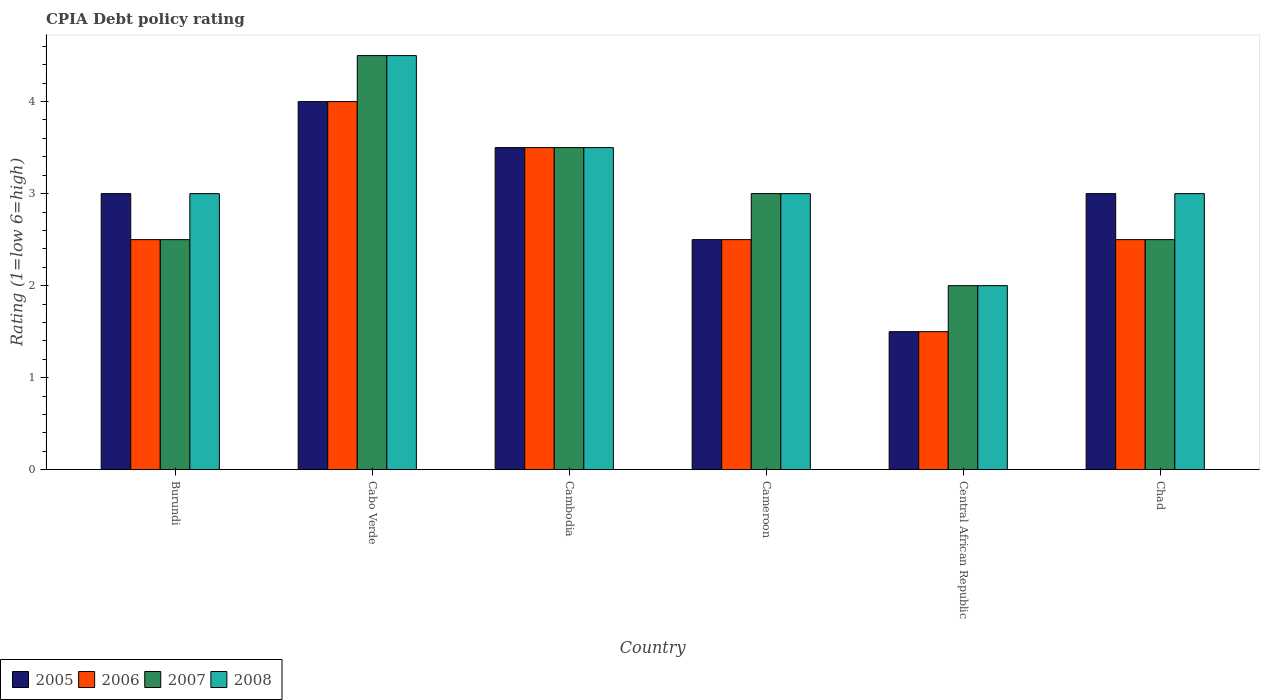How many groups of bars are there?
Offer a very short reply. 6. How many bars are there on the 5th tick from the right?
Keep it short and to the point. 4. What is the label of the 1st group of bars from the left?
Your response must be concise. Burundi. In how many cases, is the number of bars for a given country not equal to the number of legend labels?
Your response must be concise. 0. Across all countries, what is the maximum CPIA rating in 2005?
Offer a terse response. 4. Across all countries, what is the minimum CPIA rating in 2007?
Offer a very short reply. 2. In which country was the CPIA rating in 2005 maximum?
Give a very brief answer. Cabo Verde. In which country was the CPIA rating in 2008 minimum?
Make the answer very short. Central African Republic. What is the difference between the CPIA rating in 2005 in Burundi and that in Cambodia?
Keep it short and to the point. -0.5. What is the average CPIA rating in 2006 per country?
Your response must be concise. 2.75. What is the difference between the CPIA rating of/in 2005 and CPIA rating of/in 2007 in Chad?
Offer a terse response. 0.5. In how many countries, is the CPIA rating in 2006 greater than 3?
Provide a succinct answer. 2. What is the ratio of the CPIA rating in 2006 in Cabo Verde to that in Chad?
Your answer should be compact. 1.6. Is the CPIA rating in 2006 in Cabo Verde less than that in Central African Republic?
Your answer should be very brief. No. Is the difference between the CPIA rating in 2005 in Burundi and Cabo Verde greater than the difference between the CPIA rating in 2007 in Burundi and Cabo Verde?
Keep it short and to the point. Yes. What is the difference between the highest and the lowest CPIA rating in 2008?
Keep it short and to the point. 2.5. In how many countries, is the CPIA rating in 2008 greater than the average CPIA rating in 2008 taken over all countries?
Make the answer very short. 2. Is it the case that in every country, the sum of the CPIA rating in 2007 and CPIA rating in 2008 is greater than the sum of CPIA rating in 2006 and CPIA rating in 2005?
Offer a very short reply. No. Is it the case that in every country, the sum of the CPIA rating in 2006 and CPIA rating in 2005 is greater than the CPIA rating in 2008?
Offer a very short reply. Yes. How many countries are there in the graph?
Offer a terse response. 6. What is the difference between two consecutive major ticks on the Y-axis?
Keep it short and to the point. 1. Are the values on the major ticks of Y-axis written in scientific E-notation?
Provide a succinct answer. No. Does the graph contain any zero values?
Give a very brief answer. No. How many legend labels are there?
Ensure brevity in your answer.  4. How are the legend labels stacked?
Your response must be concise. Horizontal. What is the title of the graph?
Provide a succinct answer. CPIA Debt policy rating. What is the label or title of the X-axis?
Make the answer very short. Country. What is the Rating (1=low 6=high) of 2007 in Burundi?
Offer a terse response. 2.5. What is the Rating (1=low 6=high) in 2008 in Burundi?
Make the answer very short. 3. What is the Rating (1=low 6=high) in 2005 in Cabo Verde?
Your answer should be very brief. 4. What is the Rating (1=low 6=high) in 2006 in Cabo Verde?
Keep it short and to the point. 4. What is the Rating (1=low 6=high) of 2008 in Cabo Verde?
Offer a very short reply. 4.5. What is the Rating (1=low 6=high) in 2006 in Cambodia?
Keep it short and to the point. 3.5. What is the Rating (1=low 6=high) of 2005 in Cameroon?
Provide a short and direct response. 2.5. What is the Rating (1=low 6=high) in 2007 in Cameroon?
Offer a very short reply. 3. What is the Rating (1=low 6=high) of 2005 in Central African Republic?
Offer a very short reply. 1.5. What is the Rating (1=low 6=high) of 2006 in Central African Republic?
Keep it short and to the point. 1.5. What is the Rating (1=low 6=high) of 2005 in Chad?
Give a very brief answer. 3. What is the Rating (1=low 6=high) in 2006 in Chad?
Your response must be concise. 2.5. What is the Rating (1=low 6=high) in 2007 in Chad?
Your response must be concise. 2.5. Across all countries, what is the minimum Rating (1=low 6=high) in 2006?
Your response must be concise. 1.5. Across all countries, what is the minimum Rating (1=low 6=high) in 2007?
Make the answer very short. 2. Across all countries, what is the minimum Rating (1=low 6=high) of 2008?
Provide a short and direct response. 2. What is the total Rating (1=low 6=high) in 2006 in the graph?
Give a very brief answer. 16.5. What is the total Rating (1=low 6=high) of 2007 in the graph?
Offer a terse response. 18. What is the difference between the Rating (1=low 6=high) of 2006 in Burundi and that in Cabo Verde?
Your response must be concise. -1.5. What is the difference between the Rating (1=low 6=high) of 2007 in Burundi and that in Cabo Verde?
Provide a short and direct response. -2. What is the difference between the Rating (1=low 6=high) in 2008 in Burundi and that in Cabo Verde?
Give a very brief answer. -1.5. What is the difference between the Rating (1=low 6=high) in 2007 in Burundi and that in Cambodia?
Your answer should be very brief. -1. What is the difference between the Rating (1=low 6=high) of 2005 in Burundi and that in Cameroon?
Your answer should be compact. 0.5. What is the difference between the Rating (1=low 6=high) of 2006 in Burundi and that in Cameroon?
Provide a short and direct response. 0. What is the difference between the Rating (1=low 6=high) of 2007 in Burundi and that in Cameroon?
Your response must be concise. -0.5. What is the difference between the Rating (1=low 6=high) of 2005 in Burundi and that in Central African Republic?
Ensure brevity in your answer.  1.5. What is the difference between the Rating (1=low 6=high) in 2006 in Burundi and that in Chad?
Your answer should be compact. 0. What is the difference between the Rating (1=low 6=high) in 2008 in Burundi and that in Chad?
Your answer should be very brief. 0. What is the difference between the Rating (1=low 6=high) in 2005 in Cabo Verde and that in Cambodia?
Keep it short and to the point. 0.5. What is the difference between the Rating (1=low 6=high) of 2006 in Cabo Verde and that in Cambodia?
Keep it short and to the point. 0.5. What is the difference between the Rating (1=low 6=high) in 2007 in Cabo Verde and that in Cambodia?
Keep it short and to the point. 1. What is the difference between the Rating (1=low 6=high) of 2008 in Cabo Verde and that in Cambodia?
Make the answer very short. 1. What is the difference between the Rating (1=low 6=high) in 2007 in Cabo Verde and that in Cameroon?
Keep it short and to the point. 1.5. What is the difference between the Rating (1=low 6=high) in 2008 in Cabo Verde and that in Cameroon?
Keep it short and to the point. 1.5. What is the difference between the Rating (1=low 6=high) in 2006 in Cabo Verde and that in Central African Republic?
Offer a terse response. 2.5. What is the difference between the Rating (1=low 6=high) in 2007 in Cabo Verde and that in Central African Republic?
Ensure brevity in your answer.  2.5. What is the difference between the Rating (1=low 6=high) in 2005 in Cabo Verde and that in Chad?
Make the answer very short. 1. What is the difference between the Rating (1=low 6=high) of 2006 in Cabo Verde and that in Chad?
Provide a short and direct response. 1.5. What is the difference between the Rating (1=low 6=high) of 2008 in Cabo Verde and that in Chad?
Your answer should be compact. 1.5. What is the difference between the Rating (1=low 6=high) in 2005 in Cambodia and that in Cameroon?
Ensure brevity in your answer.  1. What is the difference between the Rating (1=low 6=high) in 2006 in Cambodia and that in Cameroon?
Your answer should be very brief. 1. What is the difference between the Rating (1=low 6=high) in 2007 in Cambodia and that in Cameroon?
Give a very brief answer. 0.5. What is the difference between the Rating (1=low 6=high) of 2008 in Cambodia and that in Cameroon?
Offer a terse response. 0.5. What is the difference between the Rating (1=low 6=high) in 2005 in Cambodia and that in Central African Republic?
Offer a terse response. 2. What is the difference between the Rating (1=low 6=high) in 2006 in Cambodia and that in Central African Republic?
Provide a succinct answer. 2. What is the difference between the Rating (1=low 6=high) in 2008 in Cambodia and that in Central African Republic?
Keep it short and to the point. 1.5. What is the difference between the Rating (1=low 6=high) of 2006 in Cambodia and that in Chad?
Make the answer very short. 1. What is the difference between the Rating (1=low 6=high) of 2007 in Cambodia and that in Chad?
Give a very brief answer. 1. What is the difference between the Rating (1=low 6=high) in 2005 in Cameroon and that in Chad?
Ensure brevity in your answer.  -0.5. What is the difference between the Rating (1=low 6=high) of 2008 in Cameroon and that in Chad?
Your answer should be compact. 0. What is the difference between the Rating (1=low 6=high) of 2005 in Central African Republic and that in Chad?
Offer a very short reply. -1.5. What is the difference between the Rating (1=low 6=high) of 2006 in Burundi and the Rating (1=low 6=high) of 2008 in Cabo Verde?
Provide a short and direct response. -2. What is the difference between the Rating (1=low 6=high) of 2007 in Burundi and the Rating (1=low 6=high) of 2008 in Cabo Verde?
Keep it short and to the point. -2. What is the difference between the Rating (1=low 6=high) in 2005 in Burundi and the Rating (1=low 6=high) in 2006 in Cambodia?
Your answer should be very brief. -0.5. What is the difference between the Rating (1=low 6=high) of 2006 in Burundi and the Rating (1=low 6=high) of 2007 in Cambodia?
Make the answer very short. -1. What is the difference between the Rating (1=low 6=high) in 2005 in Burundi and the Rating (1=low 6=high) in 2006 in Cameroon?
Give a very brief answer. 0.5. What is the difference between the Rating (1=low 6=high) of 2005 in Burundi and the Rating (1=low 6=high) of 2007 in Cameroon?
Your answer should be compact. 0. What is the difference between the Rating (1=low 6=high) in 2005 in Burundi and the Rating (1=low 6=high) in 2007 in Central African Republic?
Make the answer very short. 1. What is the difference between the Rating (1=low 6=high) in 2005 in Burundi and the Rating (1=low 6=high) in 2006 in Chad?
Keep it short and to the point. 0.5. What is the difference between the Rating (1=low 6=high) of 2005 in Burundi and the Rating (1=low 6=high) of 2007 in Chad?
Ensure brevity in your answer.  0.5. What is the difference between the Rating (1=low 6=high) in 2005 in Burundi and the Rating (1=low 6=high) in 2008 in Chad?
Provide a short and direct response. 0. What is the difference between the Rating (1=low 6=high) in 2006 in Burundi and the Rating (1=low 6=high) in 2008 in Chad?
Your answer should be compact. -0.5. What is the difference between the Rating (1=low 6=high) in 2005 in Cabo Verde and the Rating (1=low 6=high) in 2006 in Cambodia?
Offer a terse response. 0.5. What is the difference between the Rating (1=low 6=high) of 2005 in Cabo Verde and the Rating (1=low 6=high) of 2007 in Cambodia?
Your response must be concise. 0.5. What is the difference between the Rating (1=low 6=high) in 2006 in Cabo Verde and the Rating (1=low 6=high) in 2007 in Cambodia?
Give a very brief answer. 0.5. What is the difference between the Rating (1=low 6=high) of 2006 in Cabo Verde and the Rating (1=low 6=high) of 2008 in Cambodia?
Make the answer very short. 0.5. What is the difference between the Rating (1=low 6=high) in 2005 in Cabo Verde and the Rating (1=low 6=high) in 2006 in Cameroon?
Offer a very short reply. 1.5. What is the difference between the Rating (1=low 6=high) in 2005 in Cabo Verde and the Rating (1=low 6=high) in 2006 in Central African Republic?
Your answer should be compact. 2.5. What is the difference between the Rating (1=low 6=high) of 2005 in Cabo Verde and the Rating (1=low 6=high) of 2008 in Central African Republic?
Your response must be concise. 2. What is the difference between the Rating (1=low 6=high) of 2005 in Cabo Verde and the Rating (1=low 6=high) of 2006 in Chad?
Give a very brief answer. 1.5. What is the difference between the Rating (1=low 6=high) in 2005 in Cabo Verde and the Rating (1=low 6=high) in 2007 in Chad?
Ensure brevity in your answer.  1.5. What is the difference between the Rating (1=low 6=high) of 2005 in Cabo Verde and the Rating (1=low 6=high) of 2008 in Chad?
Ensure brevity in your answer.  1. What is the difference between the Rating (1=low 6=high) of 2006 in Cabo Verde and the Rating (1=low 6=high) of 2008 in Chad?
Provide a short and direct response. 1. What is the difference between the Rating (1=low 6=high) in 2005 in Cambodia and the Rating (1=low 6=high) in 2006 in Cameroon?
Provide a succinct answer. 1. What is the difference between the Rating (1=low 6=high) of 2005 in Cambodia and the Rating (1=low 6=high) of 2008 in Cameroon?
Offer a terse response. 0.5. What is the difference between the Rating (1=low 6=high) of 2006 in Cambodia and the Rating (1=low 6=high) of 2007 in Cameroon?
Your answer should be compact. 0.5. What is the difference between the Rating (1=low 6=high) of 2006 in Cambodia and the Rating (1=low 6=high) of 2008 in Cameroon?
Your answer should be compact. 0.5. What is the difference between the Rating (1=low 6=high) of 2007 in Cambodia and the Rating (1=low 6=high) of 2008 in Cameroon?
Your response must be concise. 0.5. What is the difference between the Rating (1=low 6=high) of 2005 in Cambodia and the Rating (1=low 6=high) of 2006 in Central African Republic?
Offer a very short reply. 2. What is the difference between the Rating (1=low 6=high) of 2006 in Cambodia and the Rating (1=low 6=high) of 2007 in Central African Republic?
Offer a very short reply. 1.5. What is the difference between the Rating (1=low 6=high) of 2007 in Cambodia and the Rating (1=low 6=high) of 2008 in Central African Republic?
Your answer should be compact. 1.5. What is the difference between the Rating (1=low 6=high) in 2006 in Cambodia and the Rating (1=low 6=high) in 2008 in Chad?
Keep it short and to the point. 0.5. What is the difference between the Rating (1=low 6=high) of 2005 in Cameroon and the Rating (1=low 6=high) of 2006 in Central African Republic?
Provide a succinct answer. 1. What is the difference between the Rating (1=low 6=high) of 2005 in Cameroon and the Rating (1=low 6=high) of 2008 in Central African Republic?
Your answer should be very brief. 0.5. What is the difference between the Rating (1=low 6=high) in 2006 in Cameroon and the Rating (1=low 6=high) in 2007 in Central African Republic?
Provide a succinct answer. 0.5. What is the difference between the Rating (1=low 6=high) of 2006 in Cameroon and the Rating (1=low 6=high) of 2008 in Chad?
Offer a terse response. -0.5. What is the difference between the Rating (1=low 6=high) in 2007 in Cameroon and the Rating (1=low 6=high) in 2008 in Chad?
Ensure brevity in your answer.  0. What is the difference between the Rating (1=low 6=high) of 2005 in Central African Republic and the Rating (1=low 6=high) of 2007 in Chad?
Make the answer very short. -1. What is the average Rating (1=low 6=high) of 2005 per country?
Your answer should be very brief. 2.92. What is the average Rating (1=low 6=high) in 2006 per country?
Provide a succinct answer. 2.75. What is the average Rating (1=low 6=high) in 2007 per country?
Offer a terse response. 3. What is the average Rating (1=low 6=high) in 2008 per country?
Keep it short and to the point. 3.17. What is the difference between the Rating (1=low 6=high) in 2005 and Rating (1=low 6=high) in 2006 in Burundi?
Keep it short and to the point. 0.5. What is the difference between the Rating (1=low 6=high) of 2005 and Rating (1=low 6=high) of 2007 in Burundi?
Provide a succinct answer. 0.5. What is the difference between the Rating (1=low 6=high) in 2005 and Rating (1=low 6=high) in 2008 in Burundi?
Offer a terse response. 0. What is the difference between the Rating (1=low 6=high) of 2006 and Rating (1=low 6=high) of 2008 in Burundi?
Your answer should be very brief. -0.5. What is the difference between the Rating (1=low 6=high) in 2005 and Rating (1=low 6=high) in 2006 in Cabo Verde?
Ensure brevity in your answer.  0. What is the difference between the Rating (1=low 6=high) of 2005 and Rating (1=low 6=high) of 2007 in Cabo Verde?
Give a very brief answer. -0.5. What is the difference between the Rating (1=low 6=high) of 2005 and Rating (1=low 6=high) of 2008 in Cabo Verde?
Provide a short and direct response. -0.5. What is the difference between the Rating (1=low 6=high) in 2006 and Rating (1=low 6=high) in 2007 in Cabo Verde?
Offer a very short reply. -0.5. What is the difference between the Rating (1=low 6=high) of 2005 and Rating (1=low 6=high) of 2006 in Cambodia?
Make the answer very short. 0. What is the difference between the Rating (1=low 6=high) in 2005 and Rating (1=low 6=high) in 2007 in Cambodia?
Make the answer very short. 0. What is the difference between the Rating (1=low 6=high) of 2005 and Rating (1=low 6=high) of 2008 in Cambodia?
Your answer should be compact. 0. What is the difference between the Rating (1=low 6=high) of 2006 and Rating (1=low 6=high) of 2008 in Cambodia?
Make the answer very short. 0. What is the difference between the Rating (1=low 6=high) of 2005 and Rating (1=low 6=high) of 2007 in Cameroon?
Your response must be concise. -0.5. What is the difference between the Rating (1=low 6=high) in 2006 and Rating (1=low 6=high) in 2007 in Cameroon?
Make the answer very short. -0.5. What is the difference between the Rating (1=low 6=high) of 2006 and Rating (1=low 6=high) of 2008 in Cameroon?
Keep it short and to the point. -0.5. What is the difference between the Rating (1=low 6=high) of 2007 and Rating (1=low 6=high) of 2008 in Cameroon?
Your answer should be compact. 0. What is the difference between the Rating (1=low 6=high) in 2005 and Rating (1=low 6=high) in 2006 in Central African Republic?
Ensure brevity in your answer.  0. What is the difference between the Rating (1=low 6=high) of 2005 and Rating (1=low 6=high) of 2007 in Central African Republic?
Your answer should be compact. -0.5. What is the difference between the Rating (1=low 6=high) of 2005 and Rating (1=low 6=high) of 2006 in Chad?
Provide a short and direct response. 0.5. What is the difference between the Rating (1=low 6=high) in 2005 and Rating (1=low 6=high) in 2008 in Chad?
Provide a short and direct response. 0. What is the difference between the Rating (1=low 6=high) in 2006 and Rating (1=low 6=high) in 2007 in Chad?
Offer a terse response. 0. What is the difference between the Rating (1=low 6=high) of 2007 and Rating (1=low 6=high) of 2008 in Chad?
Offer a very short reply. -0.5. What is the ratio of the Rating (1=low 6=high) in 2005 in Burundi to that in Cabo Verde?
Make the answer very short. 0.75. What is the ratio of the Rating (1=low 6=high) in 2007 in Burundi to that in Cabo Verde?
Make the answer very short. 0.56. What is the ratio of the Rating (1=low 6=high) in 2005 in Burundi to that in Cambodia?
Keep it short and to the point. 0.86. What is the ratio of the Rating (1=low 6=high) of 2006 in Burundi to that in Cambodia?
Give a very brief answer. 0.71. What is the ratio of the Rating (1=low 6=high) in 2007 in Burundi to that in Cambodia?
Make the answer very short. 0.71. What is the ratio of the Rating (1=low 6=high) in 2008 in Burundi to that in Cambodia?
Provide a short and direct response. 0.86. What is the ratio of the Rating (1=low 6=high) in 2008 in Burundi to that in Cameroon?
Make the answer very short. 1. What is the ratio of the Rating (1=low 6=high) in 2007 in Burundi to that in Central African Republic?
Offer a terse response. 1.25. What is the ratio of the Rating (1=low 6=high) in 2008 in Burundi to that in Central African Republic?
Offer a very short reply. 1.5. What is the ratio of the Rating (1=low 6=high) in 2005 in Burundi to that in Chad?
Ensure brevity in your answer.  1. What is the ratio of the Rating (1=low 6=high) of 2007 in Burundi to that in Chad?
Keep it short and to the point. 1. What is the ratio of the Rating (1=low 6=high) in 2008 in Burundi to that in Chad?
Your answer should be compact. 1. What is the ratio of the Rating (1=low 6=high) in 2007 in Cabo Verde to that in Cambodia?
Give a very brief answer. 1.29. What is the ratio of the Rating (1=low 6=high) in 2006 in Cabo Verde to that in Cameroon?
Provide a succinct answer. 1.6. What is the ratio of the Rating (1=low 6=high) in 2008 in Cabo Verde to that in Cameroon?
Provide a short and direct response. 1.5. What is the ratio of the Rating (1=low 6=high) of 2005 in Cabo Verde to that in Central African Republic?
Ensure brevity in your answer.  2.67. What is the ratio of the Rating (1=low 6=high) of 2006 in Cabo Verde to that in Central African Republic?
Ensure brevity in your answer.  2.67. What is the ratio of the Rating (1=low 6=high) of 2007 in Cabo Verde to that in Central African Republic?
Provide a succinct answer. 2.25. What is the ratio of the Rating (1=low 6=high) in 2008 in Cabo Verde to that in Central African Republic?
Your answer should be very brief. 2.25. What is the ratio of the Rating (1=low 6=high) of 2008 in Cabo Verde to that in Chad?
Give a very brief answer. 1.5. What is the ratio of the Rating (1=low 6=high) of 2007 in Cambodia to that in Cameroon?
Give a very brief answer. 1.17. What is the ratio of the Rating (1=low 6=high) in 2008 in Cambodia to that in Cameroon?
Your answer should be very brief. 1.17. What is the ratio of the Rating (1=low 6=high) in 2005 in Cambodia to that in Central African Republic?
Your answer should be very brief. 2.33. What is the ratio of the Rating (1=low 6=high) of 2006 in Cambodia to that in Central African Republic?
Provide a short and direct response. 2.33. What is the ratio of the Rating (1=low 6=high) in 2008 in Cambodia to that in Central African Republic?
Keep it short and to the point. 1.75. What is the ratio of the Rating (1=low 6=high) in 2005 in Cambodia to that in Chad?
Ensure brevity in your answer.  1.17. What is the ratio of the Rating (1=low 6=high) of 2006 in Cambodia to that in Chad?
Provide a succinct answer. 1.4. What is the ratio of the Rating (1=low 6=high) of 2005 in Cameroon to that in Central African Republic?
Keep it short and to the point. 1.67. What is the ratio of the Rating (1=low 6=high) in 2006 in Cameroon to that in Central African Republic?
Your answer should be very brief. 1.67. What is the ratio of the Rating (1=low 6=high) of 2007 in Cameroon to that in Central African Republic?
Your answer should be compact. 1.5. What is the ratio of the Rating (1=low 6=high) in 2006 in Cameroon to that in Chad?
Make the answer very short. 1. What is the ratio of the Rating (1=low 6=high) of 2007 in Cameroon to that in Chad?
Your answer should be very brief. 1.2. What is the ratio of the Rating (1=low 6=high) in 2008 in Cameroon to that in Chad?
Your answer should be very brief. 1. What is the ratio of the Rating (1=low 6=high) of 2005 in Central African Republic to that in Chad?
Provide a succinct answer. 0.5. What is the ratio of the Rating (1=low 6=high) of 2006 in Central African Republic to that in Chad?
Your answer should be very brief. 0.6. What is the difference between the highest and the second highest Rating (1=low 6=high) of 2005?
Make the answer very short. 0.5. What is the difference between the highest and the second highest Rating (1=low 6=high) of 2006?
Your answer should be very brief. 0.5. 